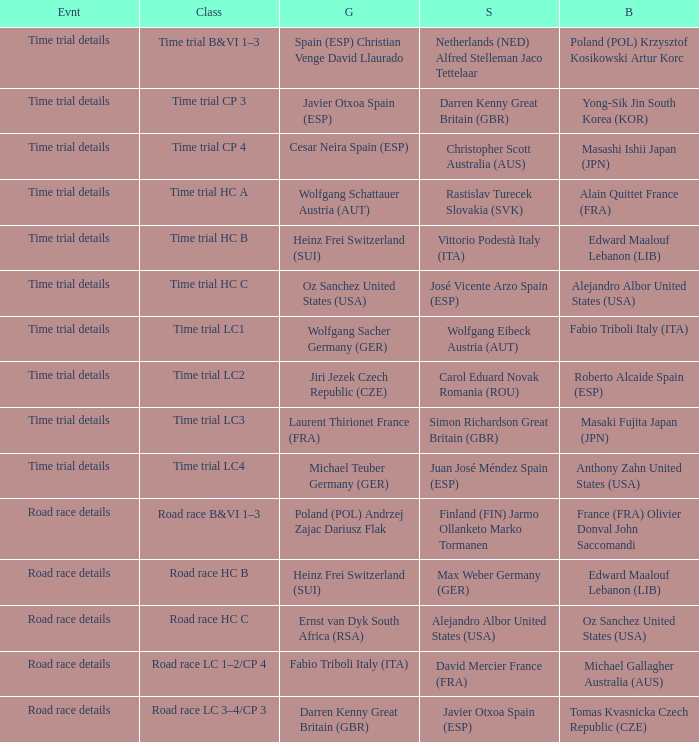Who received gold when silver is wolfgang eibeck austria (aut)? Wolfgang Sacher Germany (GER). 